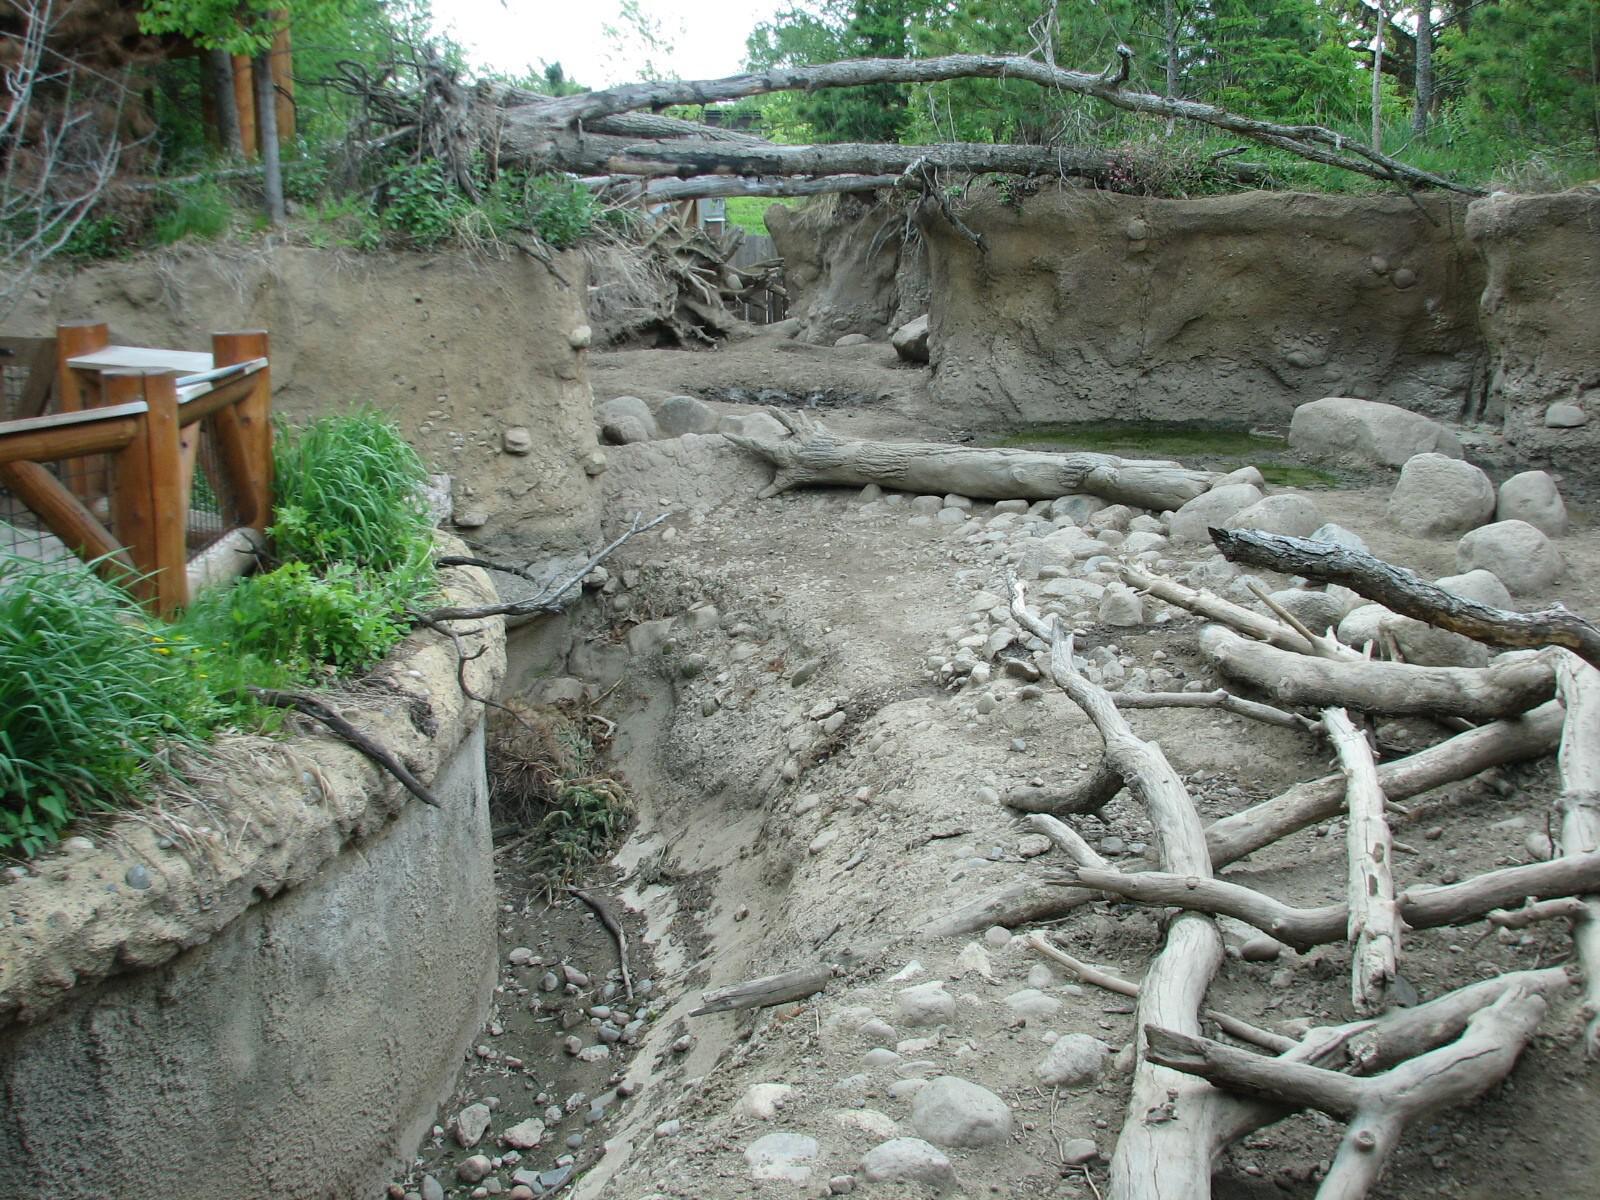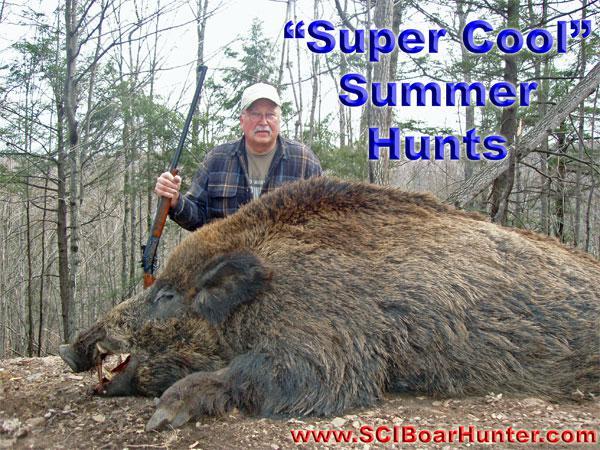The first image is the image on the left, the second image is the image on the right. Analyze the images presented: Is the assertion "At least one man is standing behind a dead wild boar holding a gun." valid? Answer yes or no. Yes. The first image is the image on the left, the second image is the image on the right. Assess this claim about the two images: "The right image contains a hunter posing with a dead boar.". Correct or not? Answer yes or no. Yes. 